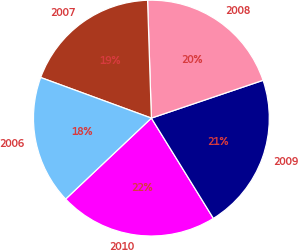Convert chart to OTSL. <chart><loc_0><loc_0><loc_500><loc_500><pie_chart><fcel>2010<fcel>2009<fcel>2008<fcel>2007<fcel>2006<nl><fcel>21.77%<fcel>21.38%<fcel>20.32%<fcel>18.89%<fcel>17.64%<nl></chart> 